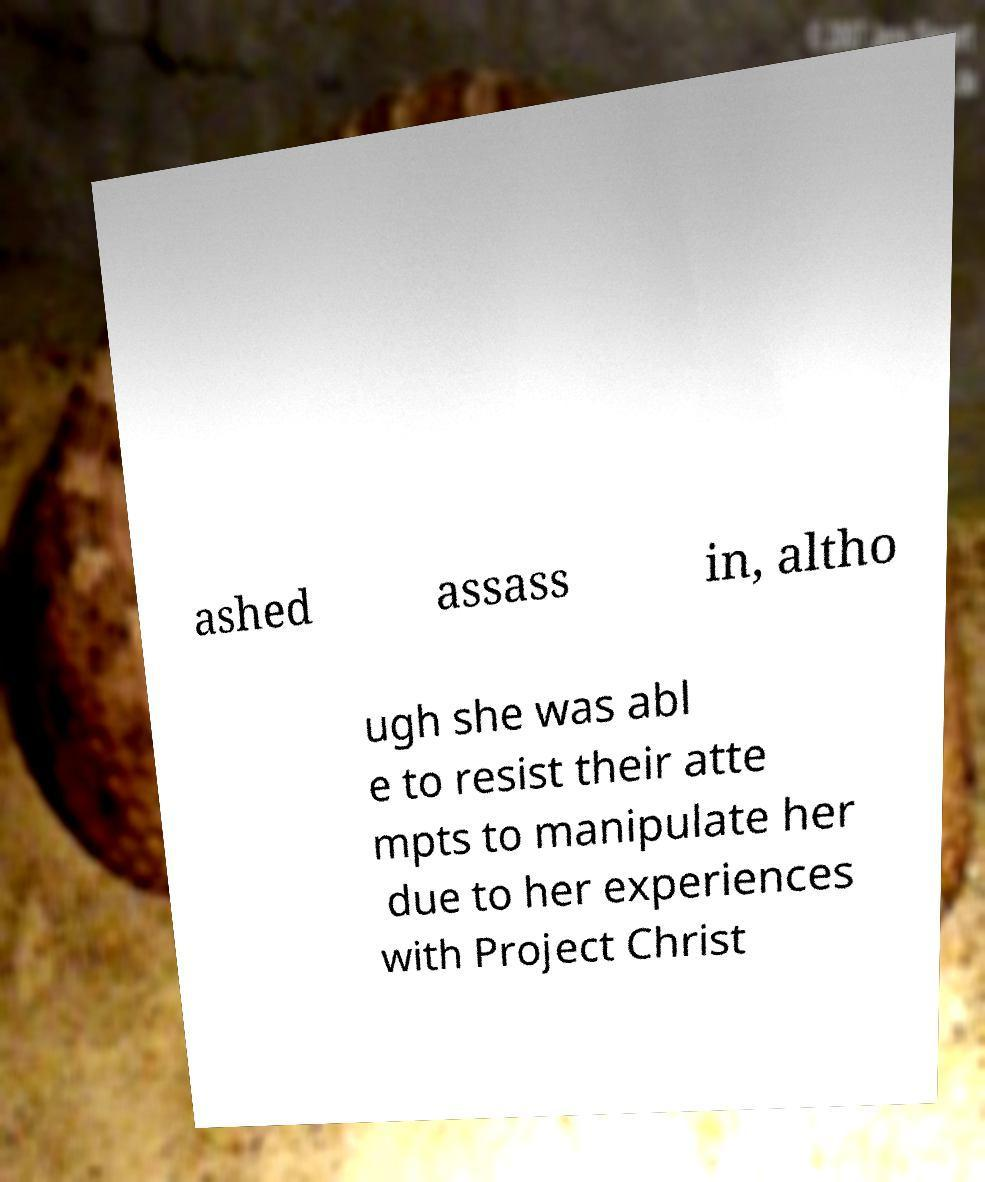There's text embedded in this image that I need extracted. Can you transcribe it verbatim? ashed assass in, altho ugh she was abl e to resist their atte mpts to manipulate her due to her experiences with Project Christ 